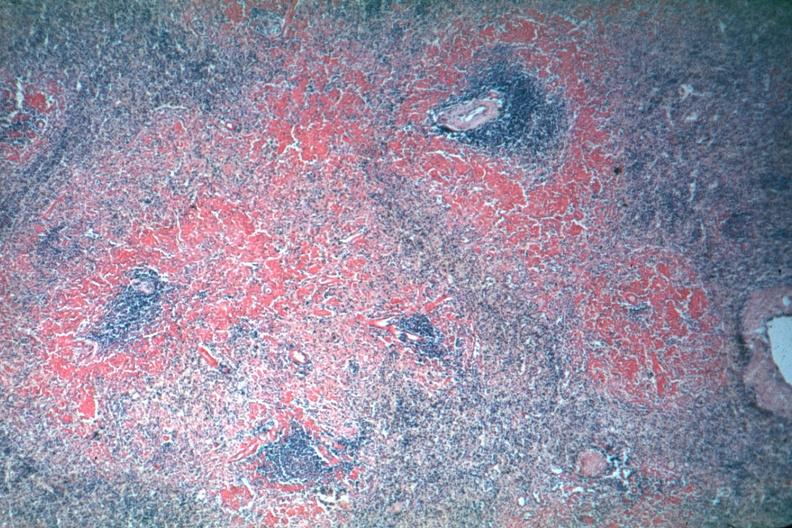what are well shown though exposure is not the best?
Answer the question using a single word or phrase. Red perifollicular amyloid deposits 